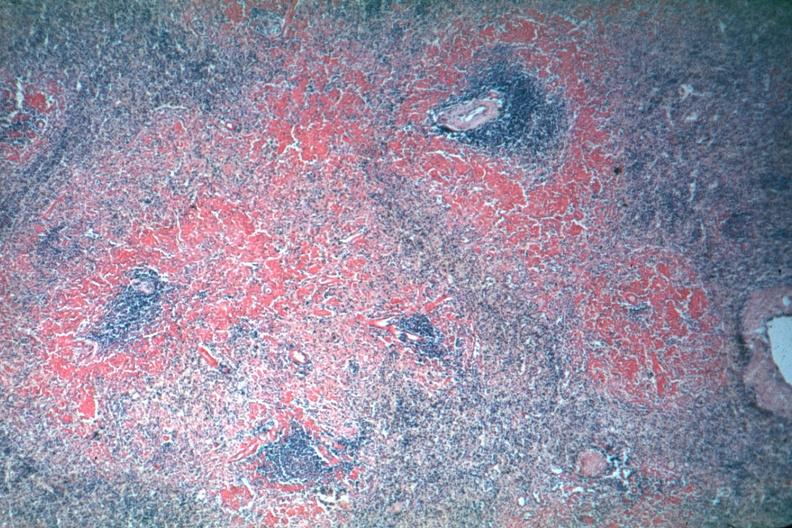what are well shown though exposure is not the best?
Answer the question using a single word or phrase. Red perifollicular amyloid deposits 